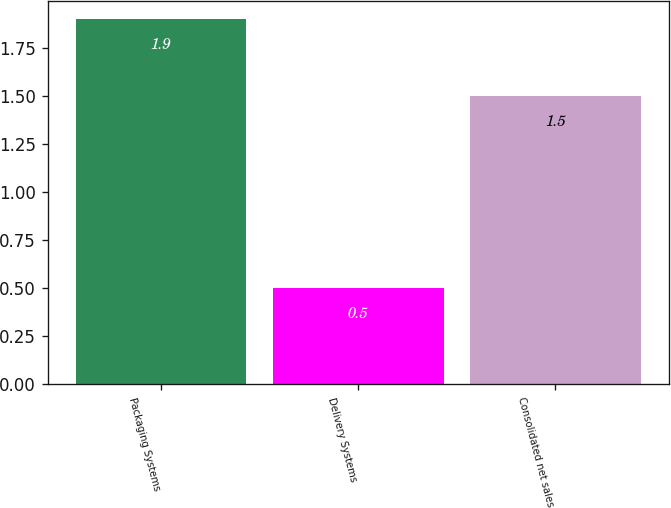<chart> <loc_0><loc_0><loc_500><loc_500><bar_chart><fcel>Packaging Systems<fcel>Delivery Systems<fcel>Consolidated net sales<nl><fcel>1.9<fcel>0.5<fcel>1.5<nl></chart> 